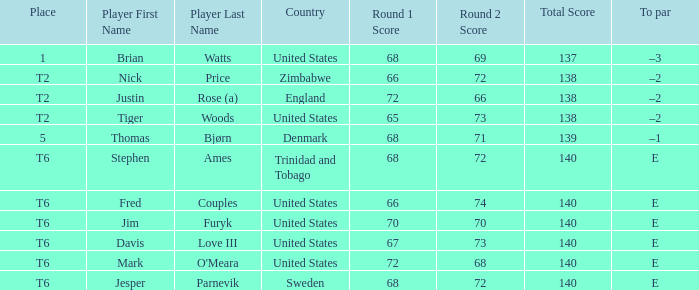With a score of 68-69=137, what was the to par for the respective player? –3. 